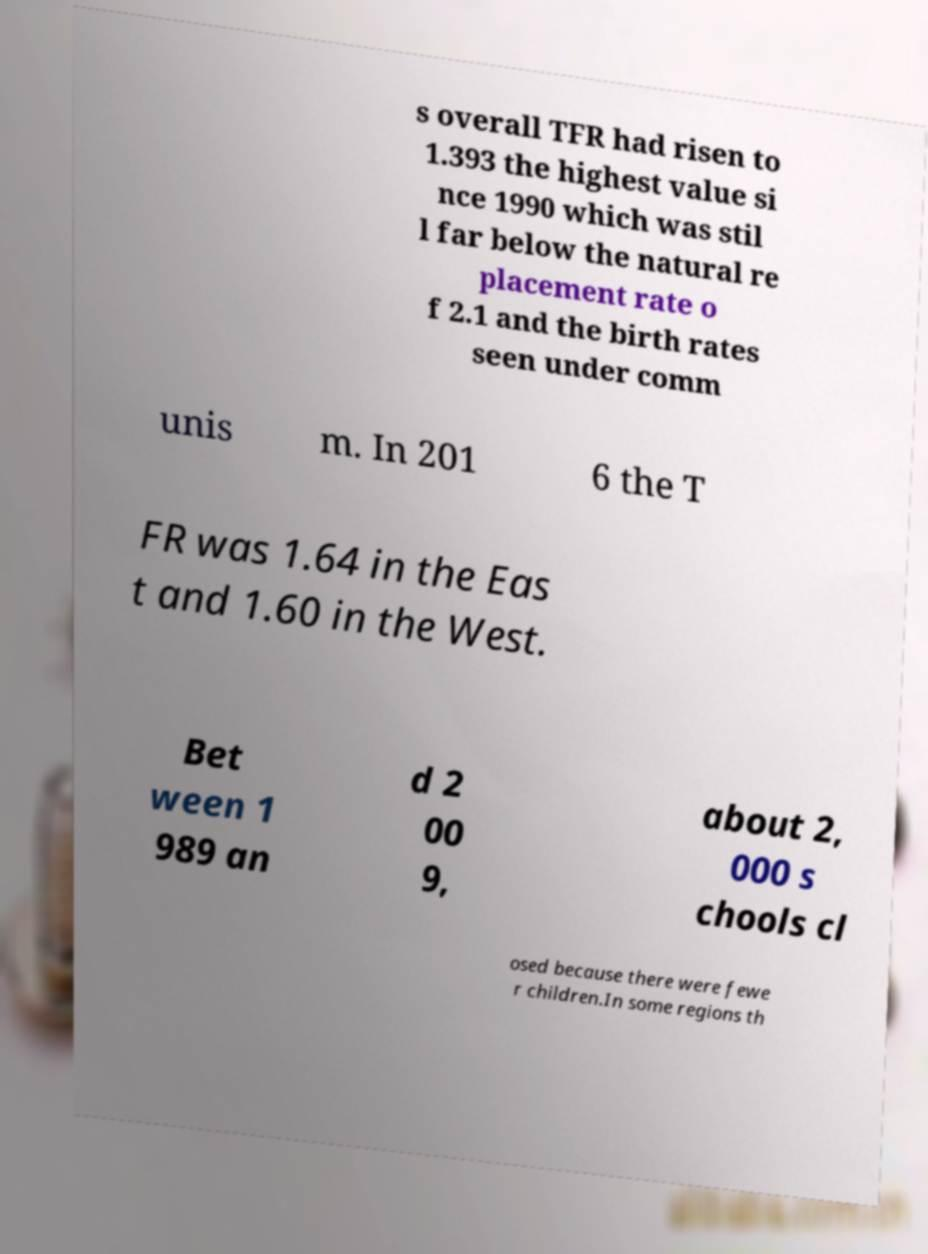For documentation purposes, I need the text within this image transcribed. Could you provide that? s overall TFR had risen to 1.393 the highest value si nce 1990 which was stil l far below the natural re placement rate o f 2.1 and the birth rates seen under comm unis m. In 201 6 the T FR was 1.64 in the Eas t and 1.60 in the West. Bet ween 1 989 an d 2 00 9, about 2, 000 s chools cl osed because there were fewe r children.In some regions th 